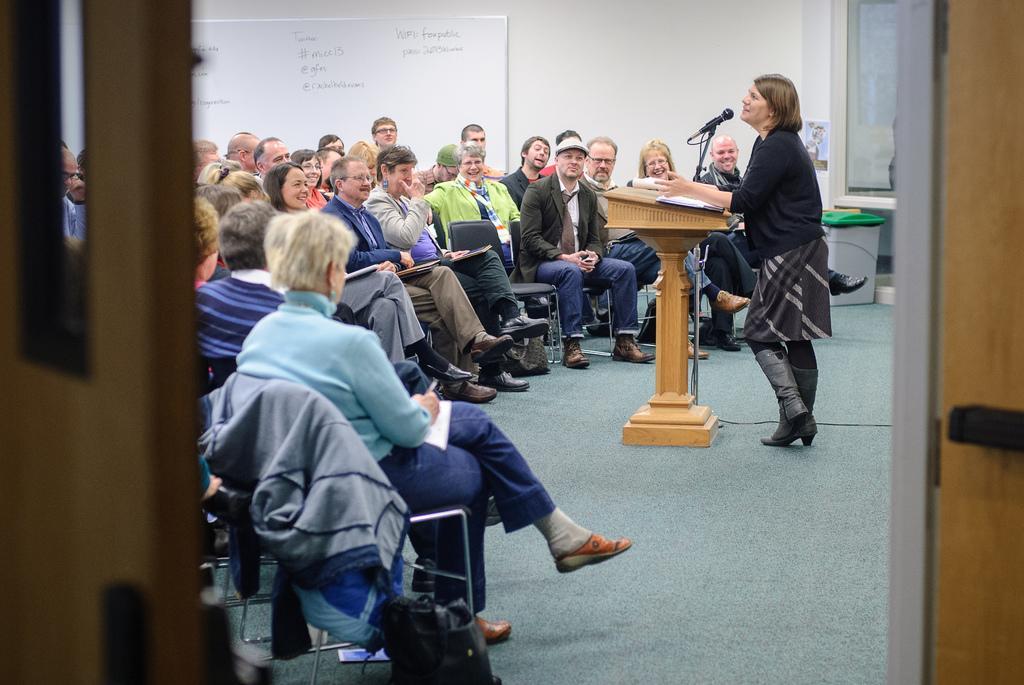Could you give a brief overview of what you see in this image? In the image we can see there are many people sitting and one is standing, they are wearing clothes and shoes. We can even see there are many chairs and the floor. Here we can see the podium, microphone, cable wire, whiteboard and text on the board. 